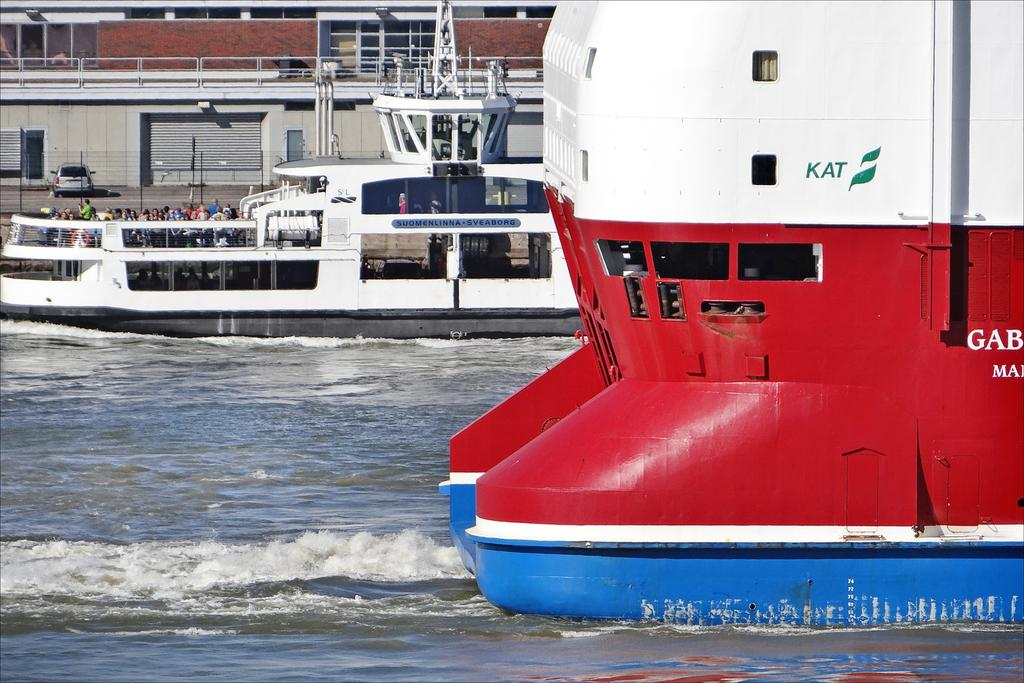<image>
Provide a brief description of the given image. A boat in white, red, and blue with KAT in green on the side. 